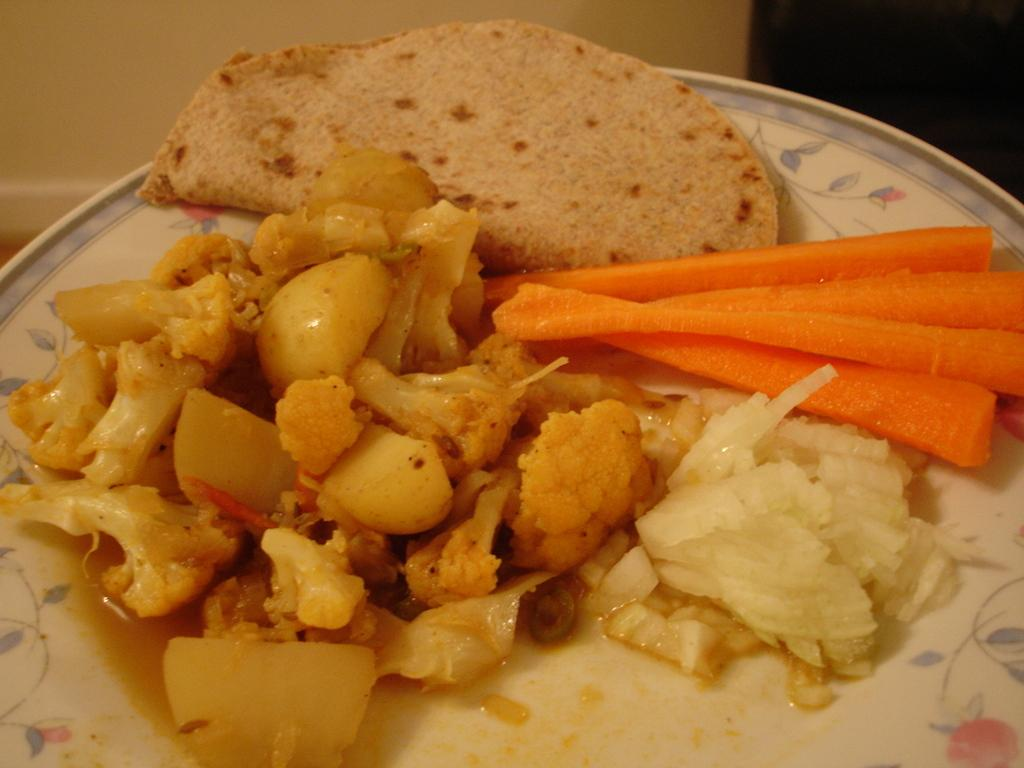What is the main subject of the image? The main subject of the image is food. Can you describe the location of the food in the image? The food is in the center of a plate. How many eyes can be seen on the van in the image? There is no van present in the image, and therefore no eyes can be seen on it. 